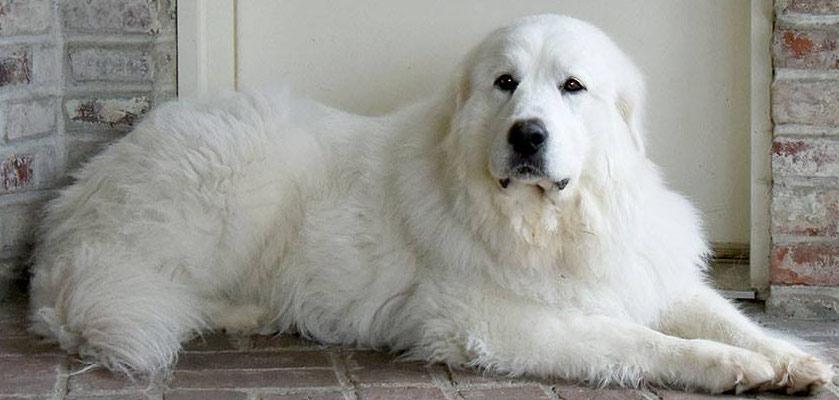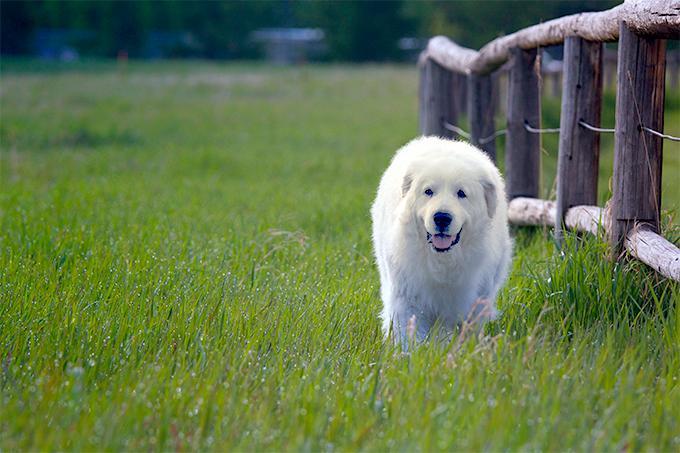The first image is the image on the left, the second image is the image on the right. For the images shown, is this caption "There is at least one dog not in the grass" true? Answer yes or no. Yes. The first image is the image on the left, the second image is the image on the right. Assess this claim about the two images: "In one image there is a white dog outside in the grass.". Correct or not? Answer yes or no. Yes. 